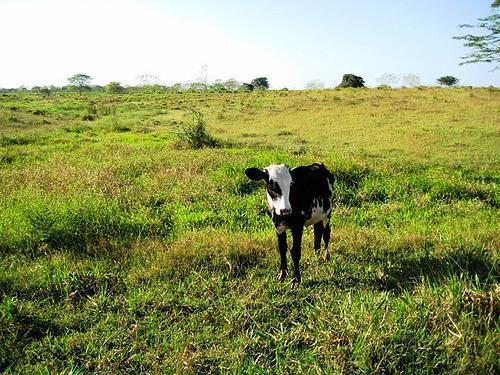How many buildings are visible in the picture?
Give a very brief answer. 0. How many cows can be seen?
Give a very brief answer. 1. 